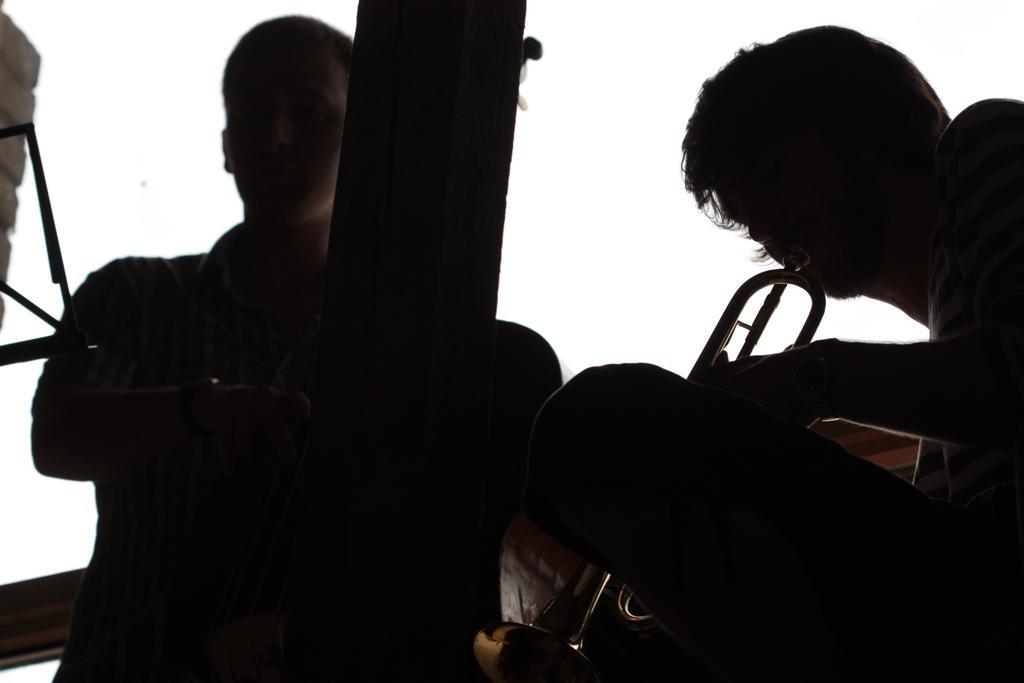Can you describe this image briefly? In this image we can see few people. A person playing a musical instrument at the right side of the image. There is an object at the left side of the image. We can see the sky in the image. 